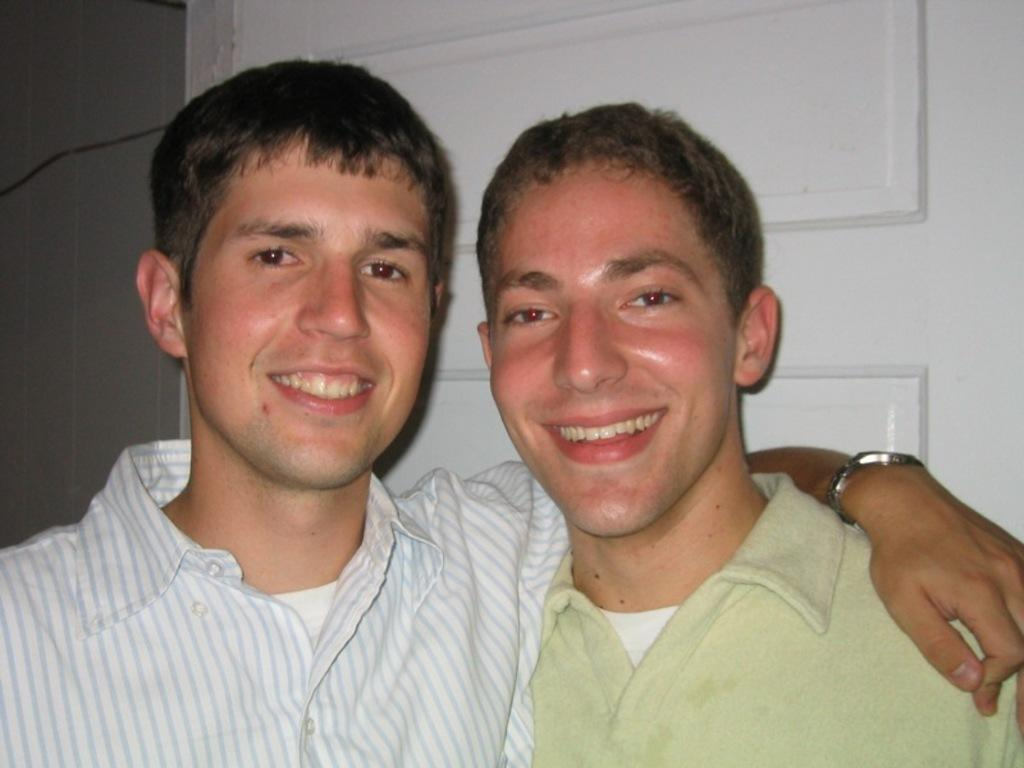How many people are in the image? There are two men in the image. What is the facial expression of the men in the image? Both men are smiling. Can you describe any accessories worn by the men in the image? The man on the left is wearing a watch. What can be seen in the background of the image? There is a door visible in the background of the image. What type of support can be seen in the image? There is no support visible in the image. What kind of plough is being used by the men in the image? There are no ploughs present in the image; it features two men smiling. 